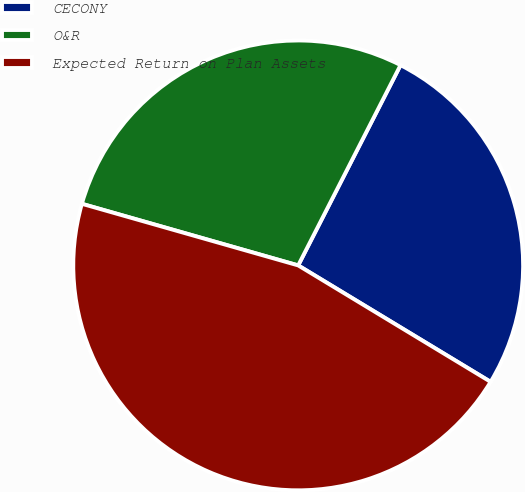<chart> <loc_0><loc_0><loc_500><loc_500><pie_chart><fcel>CECONY<fcel>O&R<fcel>Expected Return on Plan Assets<nl><fcel>26.14%<fcel>28.1%<fcel>45.75%<nl></chart> 